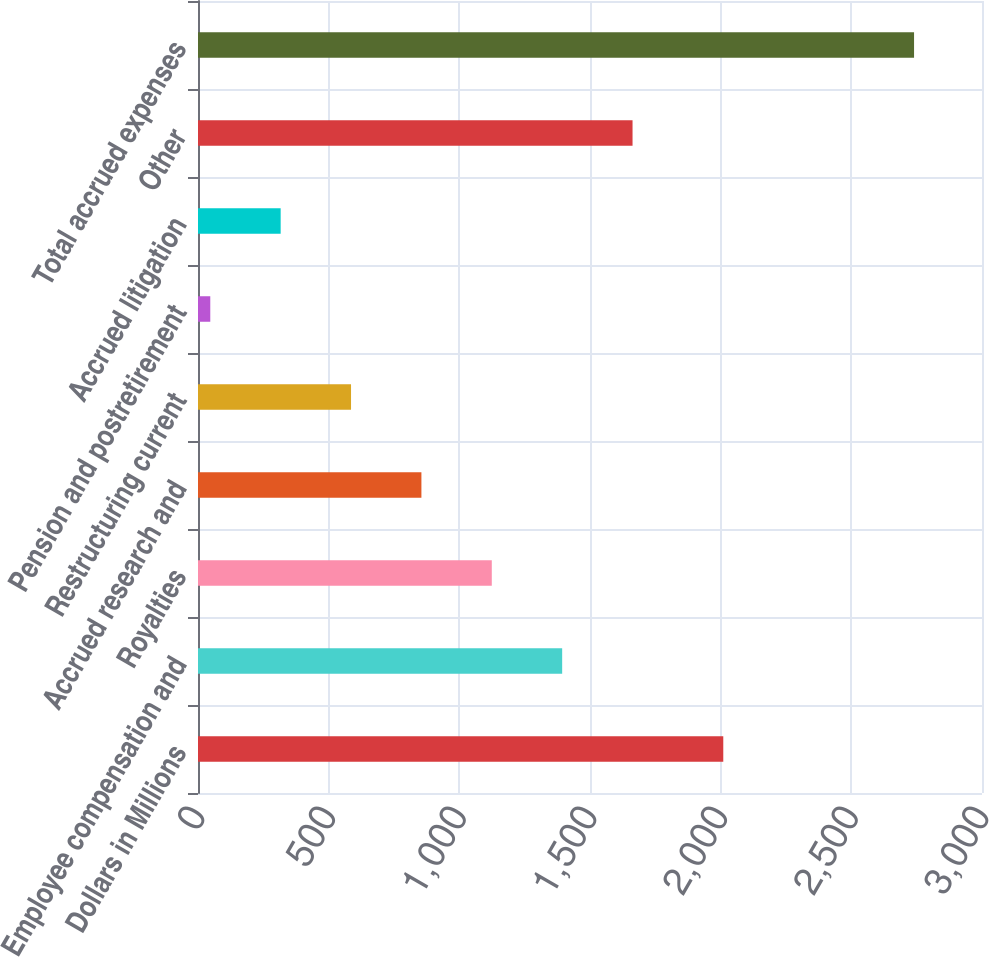Convert chart to OTSL. <chart><loc_0><loc_0><loc_500><loc_500><bar_chart><fcel>Dollars in Millions<fcel>Employee compensation and<fcel>Royalties<fcel>Accrued research and<fcel>Restructuringcurrent<fcel>Pension and postretirement<fcel>Accrued litigation<fcel>Other<fcel>Total accrued expenses<nl><fcel>2010<fcel>1393.5<fcel>1124.2<fcel>854.9<fcel>585.6<fcel>47<fcel>316.3<fcel>1662.8<fcel>2740<nl></chart> 